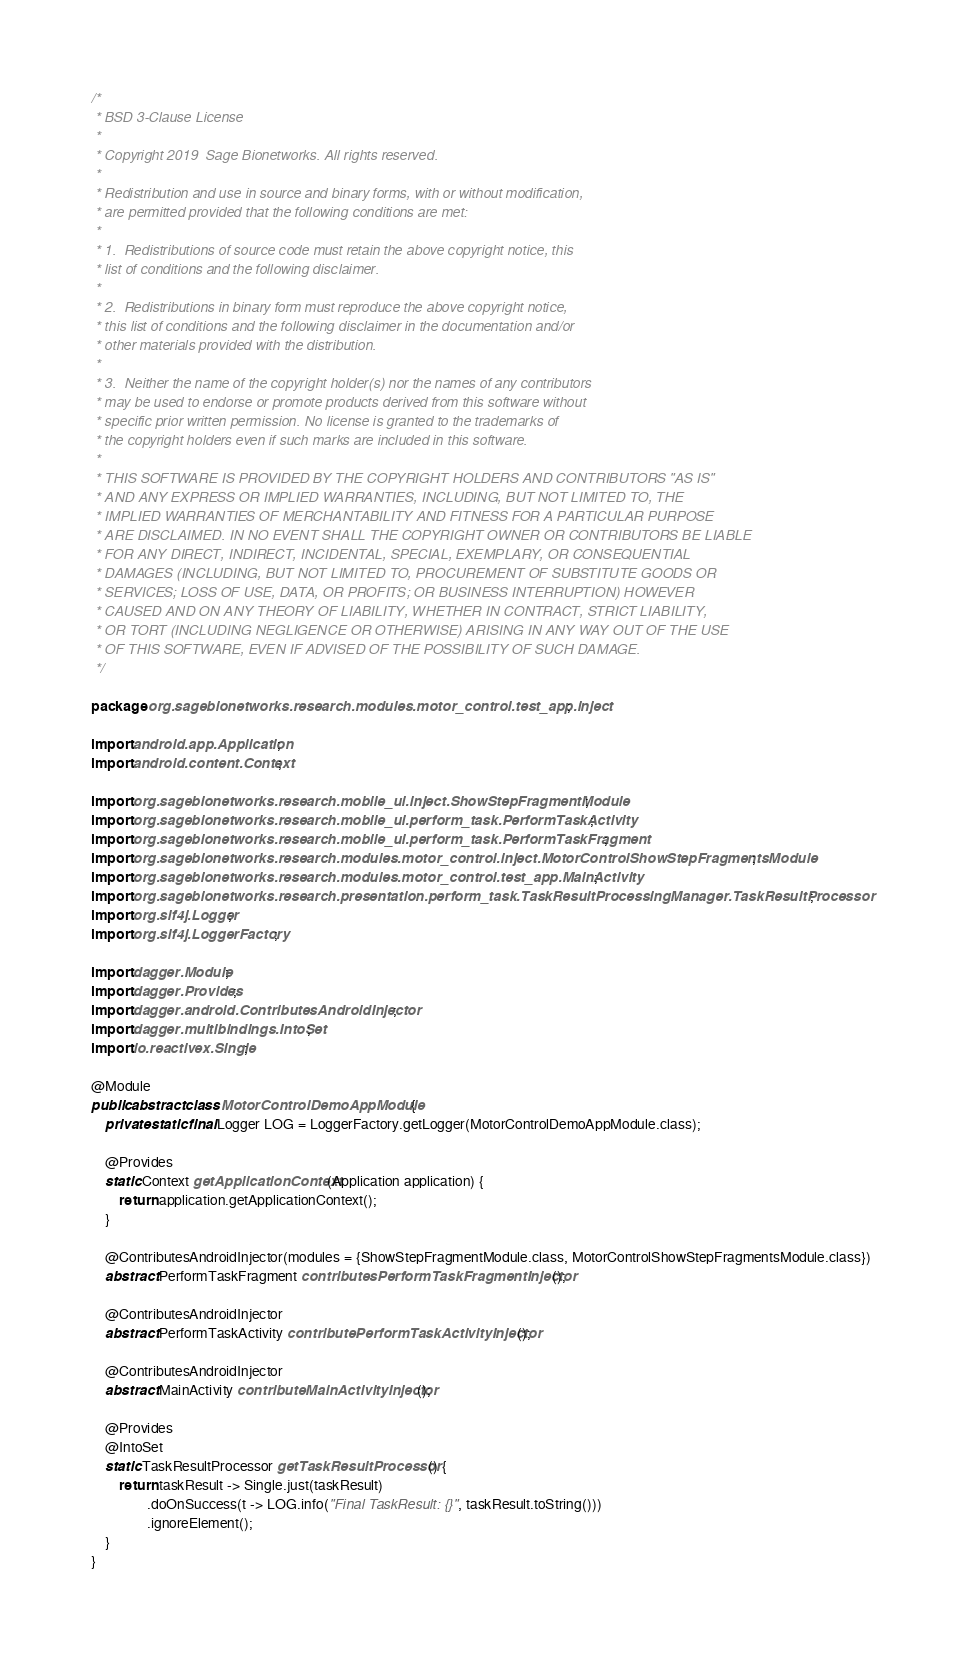Convert code to text. <code><loc_0><loc_0><loc_500><loc_500><_Java_>/*
 * BSD 3-Clause License
 *
 * Copyright 2019  Sage Bionetworks. All rights reserved.
 *
 * Redistribution and use in source and binary forms, with or without modification,
 * are permitted provided that the following conditions are met:
 *
 * 1.  Redistributions of source code must retain the above copyright notice, this
 * list of conditions and the following disclaimer.
 *
 * 2.  Redistributions in binary form must reproduce the above copyright notice,
 * this list of conditions and the following disclaimer in the documentation and/or
 * other materials provided with the distribution.
 *
 * 3.  Neither the name of the copyright holder(s) nor the names of any contributors
 * may be used to endorse or promote products derived from this software without
 * specific prior written permission. No license is granted to the trademarks of
 * the copyright holders even if such marks are included in this software.
 *
 * THIS SOFTWARE IS PROVIDED BY THE COPYRIGHT HOLDERS AND CONTRIBUTORS "AS IS"
 * AND ANY EXPRESS OR IMPLIED WARRANTIES, INCLUDING, BUT NOT LIMITED TO, THE
 * IMPLIED WARRANTIES OF MERCHANTABILITY AND FITNESS FOR A PARTICULAR PURPOSE
 * ARE DISCLAIMED. IN NO EVENT SHALL THE COPYRIGHT OWNER OR CONTRIBUTORS BE LIABLE
 * FOR ANY DIRECT, INDIRECT, INCIDENTAL, SPECIAL, EXEMPLARY, OR CONSEQUENTIAL
 * DAMAGES (INCLUDING, BUT NOT LIMITED TO, PROCUREMENT OF SUBSTITUTE GOODS OR
 * SERVICES; LOSS OF USE, DATA, OR PROFITS; OR BUSINESS INTERRUPTION) HOWEVER
 * CAUSED AND ON ANY THEORY OF LIABILITY, WHETHER IN CONTRACT, STRICT LIABILITY,
 * OR TORT (INCLUDING NEGLIGENCE OR OTHERWISE) ARISING IN ANY WAY OUT OF THE USE
 * OF THIS SOFTWARE, EVEN IF ADVISED OF THE POSSIBILITY OF SUCH DAMAGE.
 */

package org.sagebionetworks.research.modules.motor_control.test_app.inject;

import android.app.Application;
import android.content.Context;

import org.sagebionetworks.research.mobile_ui.inject.ShowStepFragmentModule;
import org.sagebionetworks.research.mobile_ui.perform_task.PerformTaskActivity;
import org.sagebionetworks.research.mobile_ui.perform_task.PerformTaskFragment;
import org.sagebionetworks.research.modules.motor_control.inject.MotorControlShowStepFragmentsModule;
import org.sagebionetworks.research.modules.motor_control.test_app.MainActivity;
import org.sagebionetworks.research.presentation.perform_task.TaskResultProcessingManager.TaskResultProcessor;
import org.slf4j.Logger;
import org.slf4j.LoggerFactory;

import dagger.Module;
import dagger.Provides;
import dagger.android.ContributesAndroidInjector;
import dagger.multibindings.IntoSet;
import io.reactivex.Single;

@Module
public abstract class MotorControlDemoAppModule {
    private static final Logger LOG = LoggerFactory.getLogger(MotorControlDemoAppModule.class);

    @Provides
    static Context getApplicationContext(Application application) {
        return application.getApplicationContext();
    }

    @ContributesAndroidInjector(modules = {ShowStepFragmentModule.class, MotorControlShowStepFragmentsModule.class})
    abstract PerformTaskFragment contributesPerformTaskFragmentInjector();

    @ContributesAndroidInjector
    abstract PerformTaskActivity contributePerformTaskActivityInjector();

    @ContributesAndroidInjector
    abstract MainActivity contributeMainActivityInjector();

    @Provides
    @IntoSet
    static TaskResultProcessor getTaskResultProcessor() {
        return taskResult -> Single.just(taskResult)
                .doOnSuccess(t -> LOG.info("Final TaskResult: {}", taskResult.toString()))
                .ignoreElement();
    }
}
</code> 